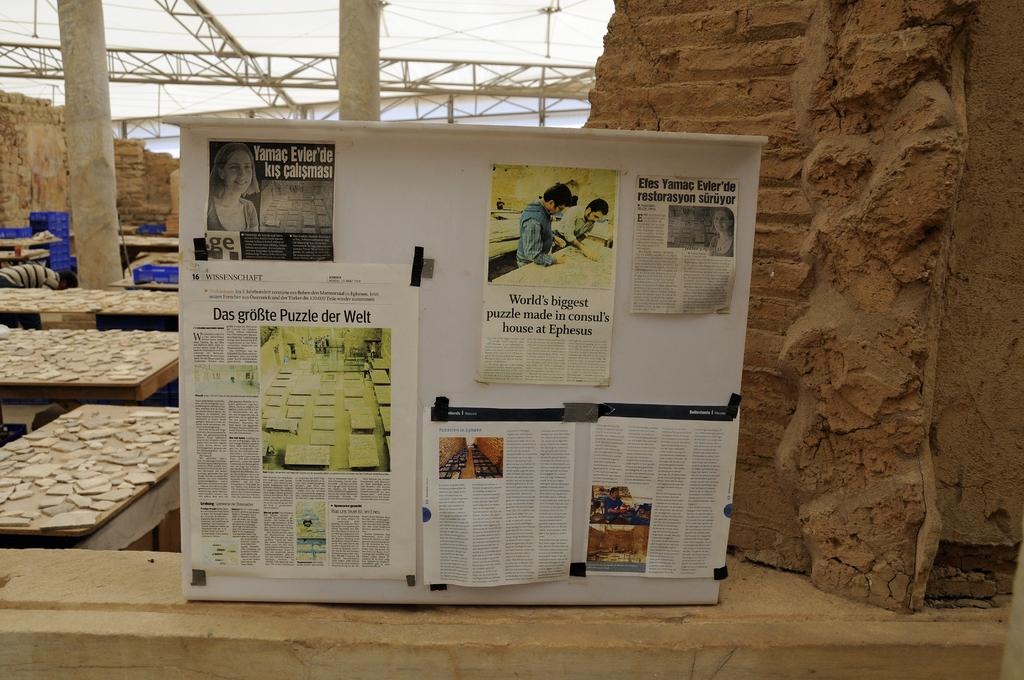<image>
Offer a succinct explanation of the picture presented. Newspaper clipping of World's biggest puzzle made in consul's house at Ephesus are pinned to a board. 